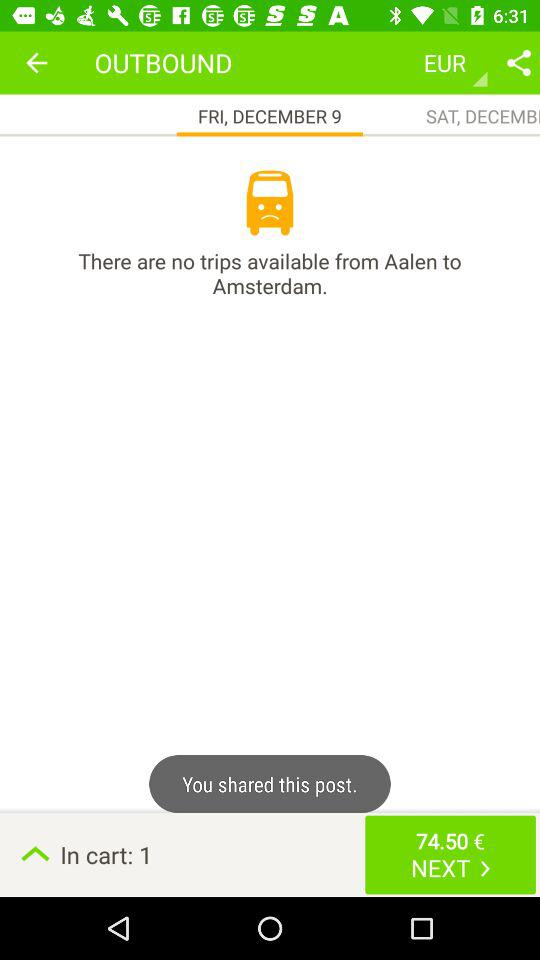How many items are there in the cart? There is 1 item in the cart. 